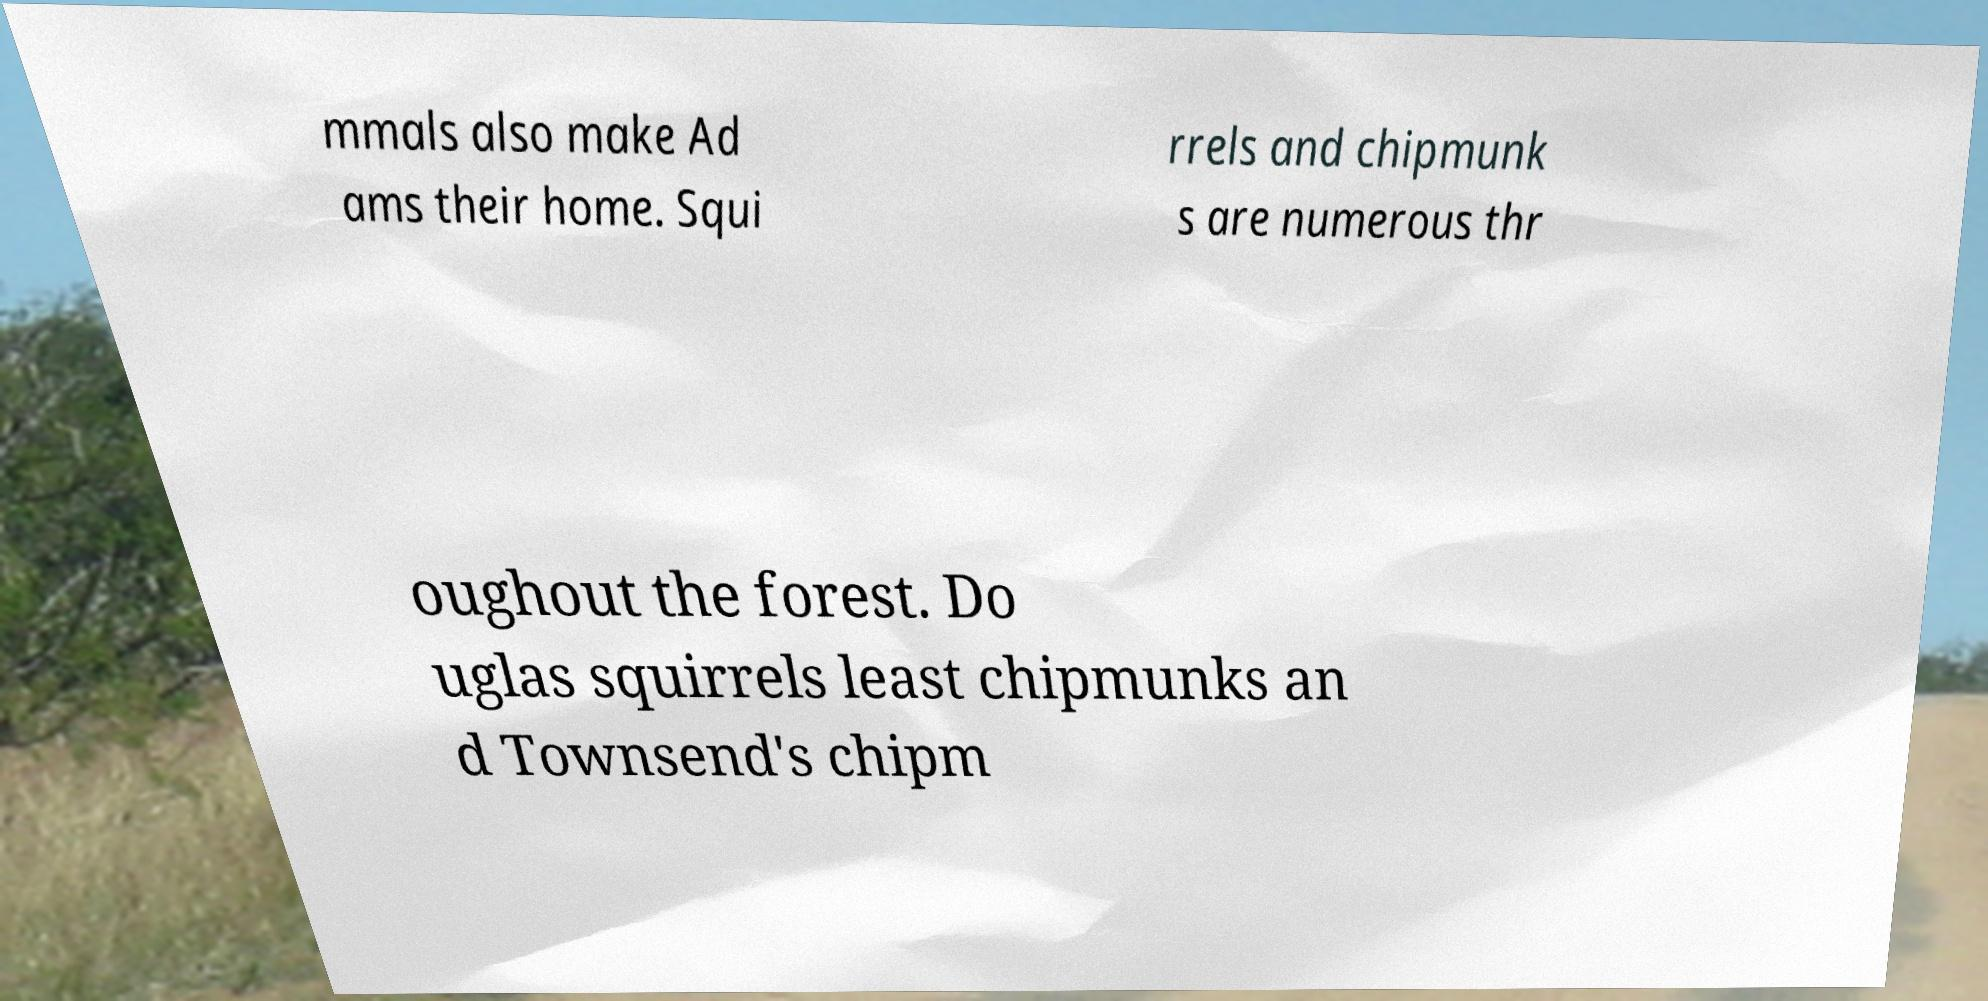Can you accurately transcribe the text from the provided image for me? mmals also make Ad ams their home. Squi rrels and chipmunk s are numerous thr oughout the forest. Do uglas squirrels least chipmunks an d Townsend's chipm 